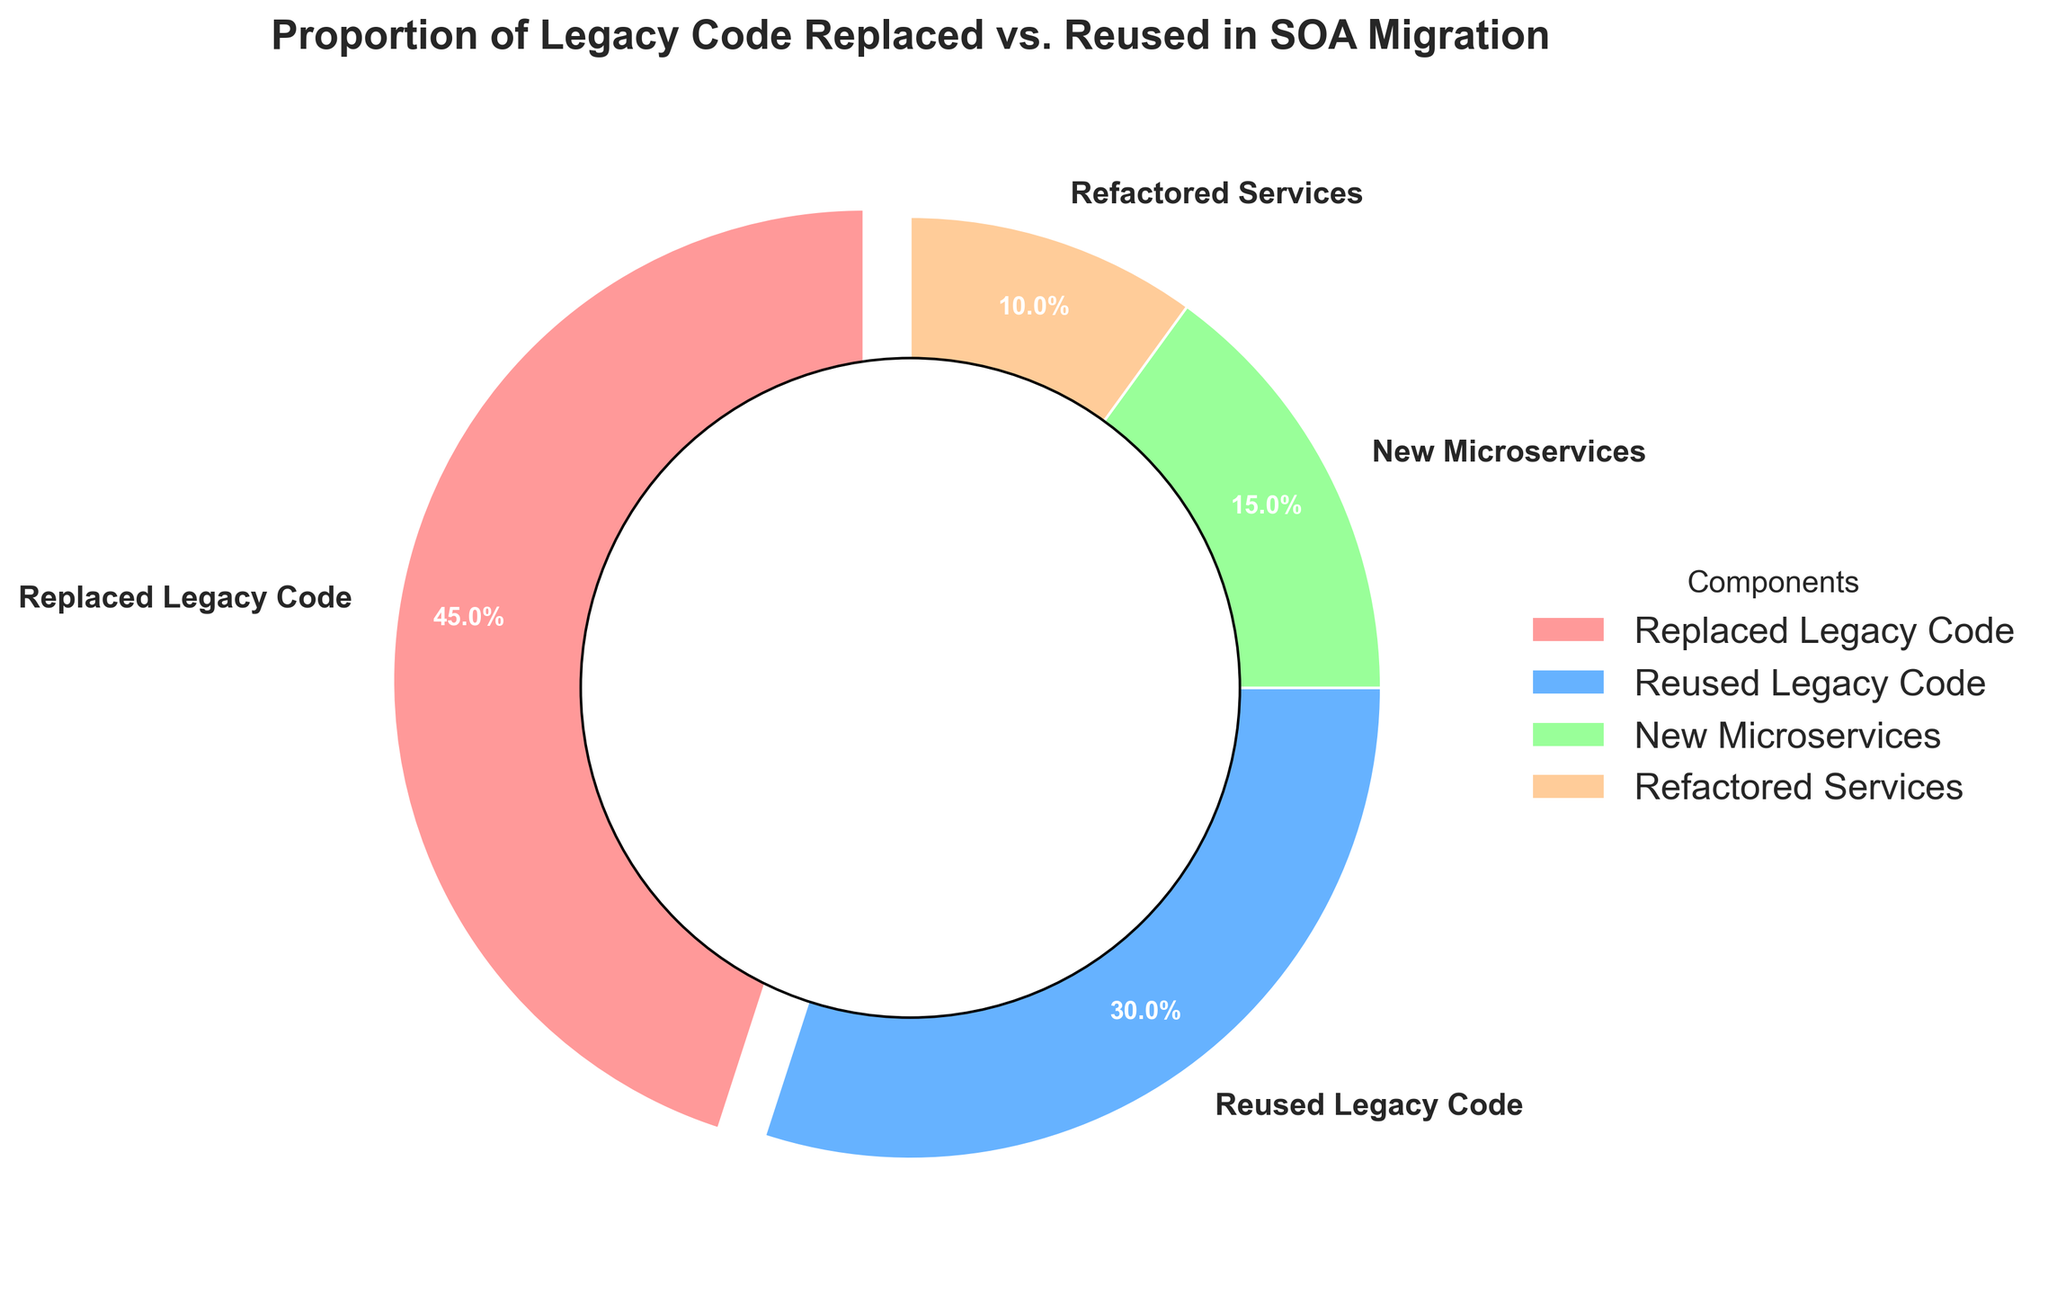what percentage of the legacy code was either replaced or reused? The percentage of legacy code replaced is 45%, and the percentage reused is 30%. Adding these together gives 45% + 30% = 75%.
Answer: 75% Which component has the largest proportion in the SOA migration? By looking at the pie chart, the segment labeled "Replaced Legacy Code" is the largest.
Answer: Replaced Legacy Code What is the difference in proportion between new microservices and refactored services? The percentage for new microservices is 15%, and for refactored services, it is 10%. The difference is 15% - 10% = 5%.
Answer: 5% Which component is represented by the green color? Referring to the chart, the green color segment is labeled "Reused Legacy Code".
Answer: Reused Legacy Code What fraction of the original legacy code was neither replaced nor reused? The components that represent legacy code are replaced and reused. The total percentage of these components is 45% + 30% = 75%. Therefore, the remaining legacy code, which was neither replaced nor reused, is 100% - 75% = 25%.
Answer: 25% Can you identify which component is slightly separated (exploded) from the chart? In the pie chart, the segment that is slightly separated from the rest is labeled "Replaced Legacy Code".
Answer: Replaced Legacy Code Compare the combined percentage of new microservices and refactored services to that of reused legacy code. Which is greater? The combined percentage of new microservices and refactored services is 15% + 10% = 25%. The percentage for reused legacy code is 30%. Comparing these two values, 30% is greater than 25%.
Answer: Reused Legacy Code What is the visual difference between the 'Replaced Legacy Code' and 'Reused Legacy Code' segments? The 'Replaced Legacy Code' segment is both the largest and is slightly separated (exploded) from the rest of the pie chart, while 'Reused Legacy Code' is represented with a green color.
Answer: Largest and exploded Calculate the average percentage of new microservices and refactored services. The percentage for new microservices is 15%, and for refactored services, it is 10%. The average is calculated as (15% + 10%) / 2 = 12.5%.
Answer: 12.5% Which component has the smallest proportion, and what is its percentage? By examining the pie chart, the segment labeled "Refactored Services" is the smallest, with a proportion of 10%.
Answer: Refactored Services 